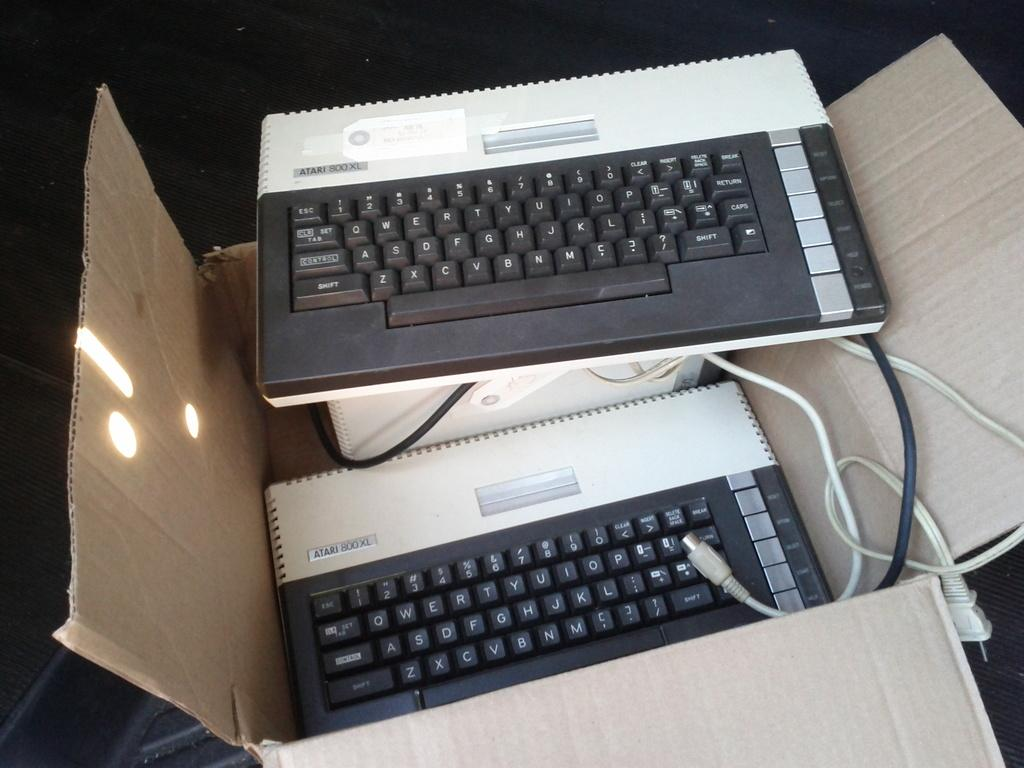<image>
Describe the image concisely. Two Atari 800 keyboards, one in a box and one on top of the box. 